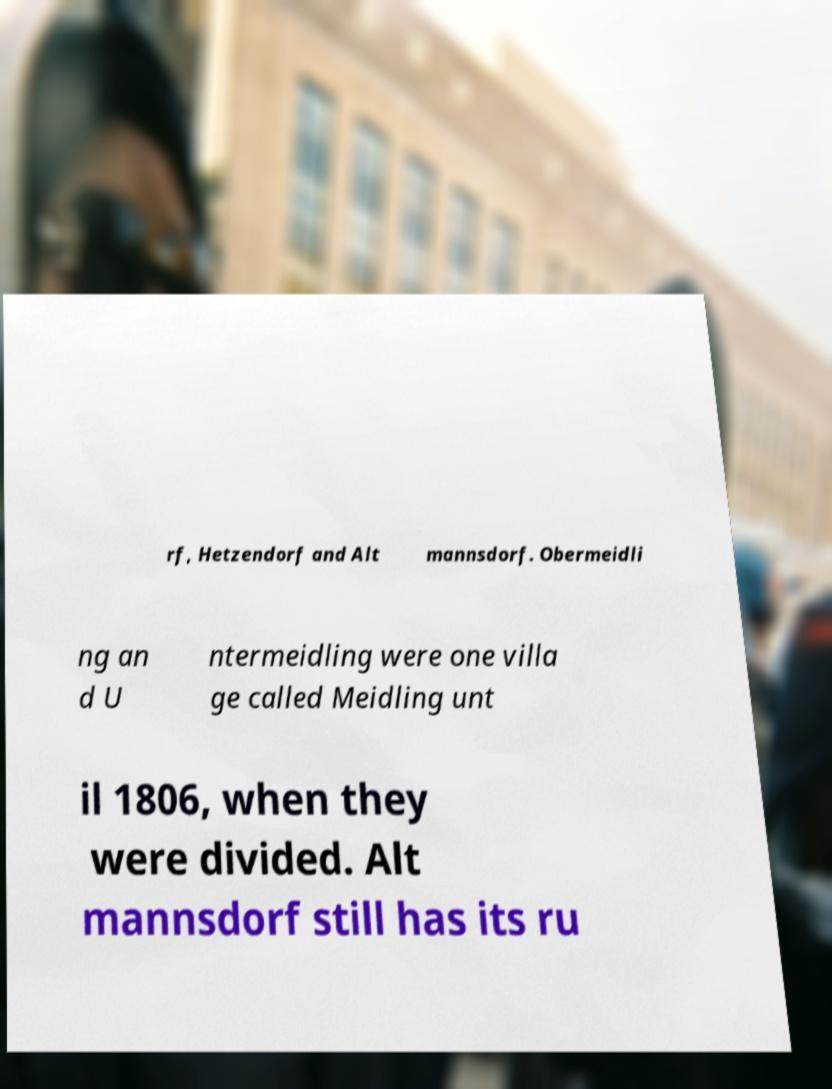There's text embedded in this image that I need extracted. Can you transcribe it verbatim? rf, Hetzendorf and Alt mannsdorf. Obermeidli ng an d U ntermeidling were one villa ge called Meidling unt il 1806, when they were divided. Alt mannsdorf still has its ru 